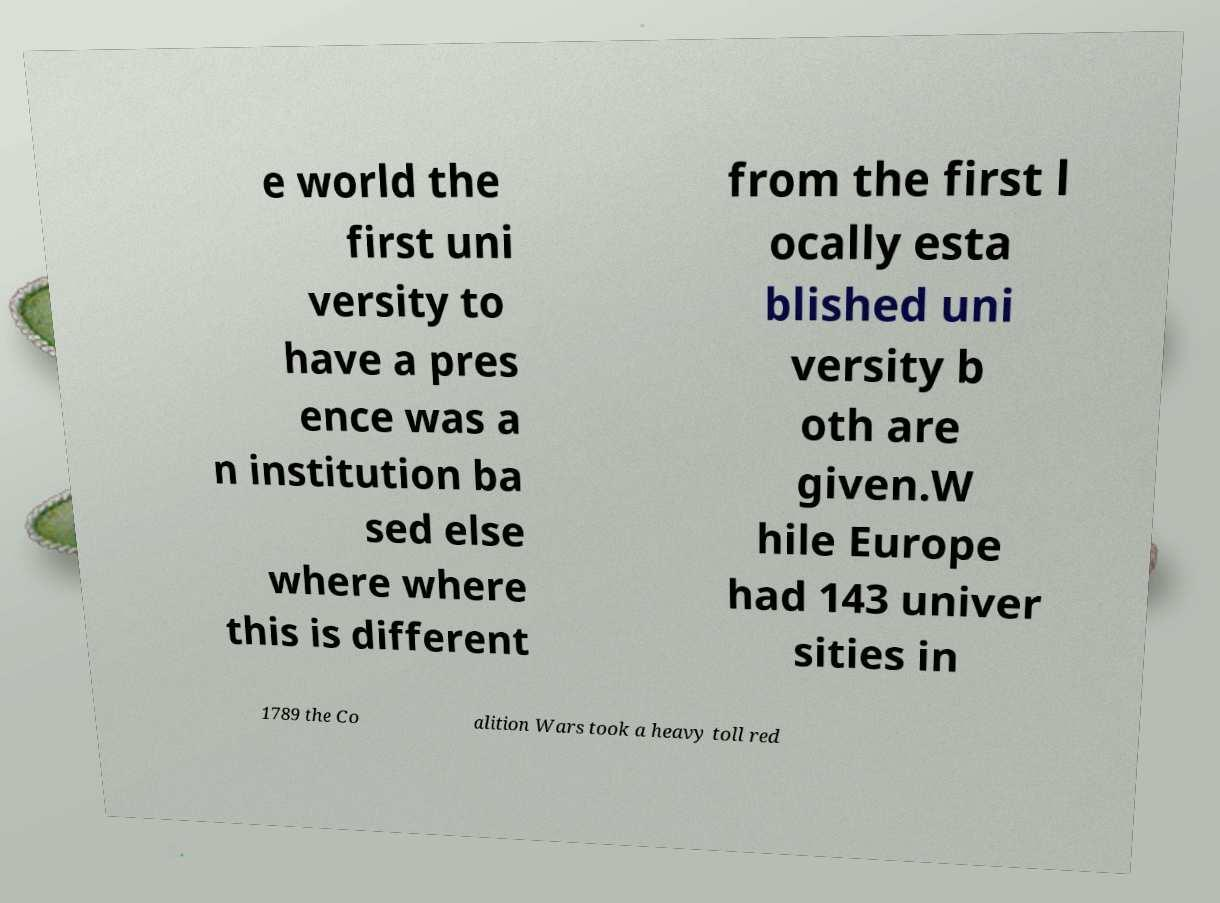I need the written content from this picture converted into text. Can you do that? e world the first uni versity to have a pres ence was a n institution ba sed else where where this is different from the first l ocally esta blished uni versity b oth are given.W hile Europe had 143 univer sities in 1789 the Co alition Wars took a heavy toll red 